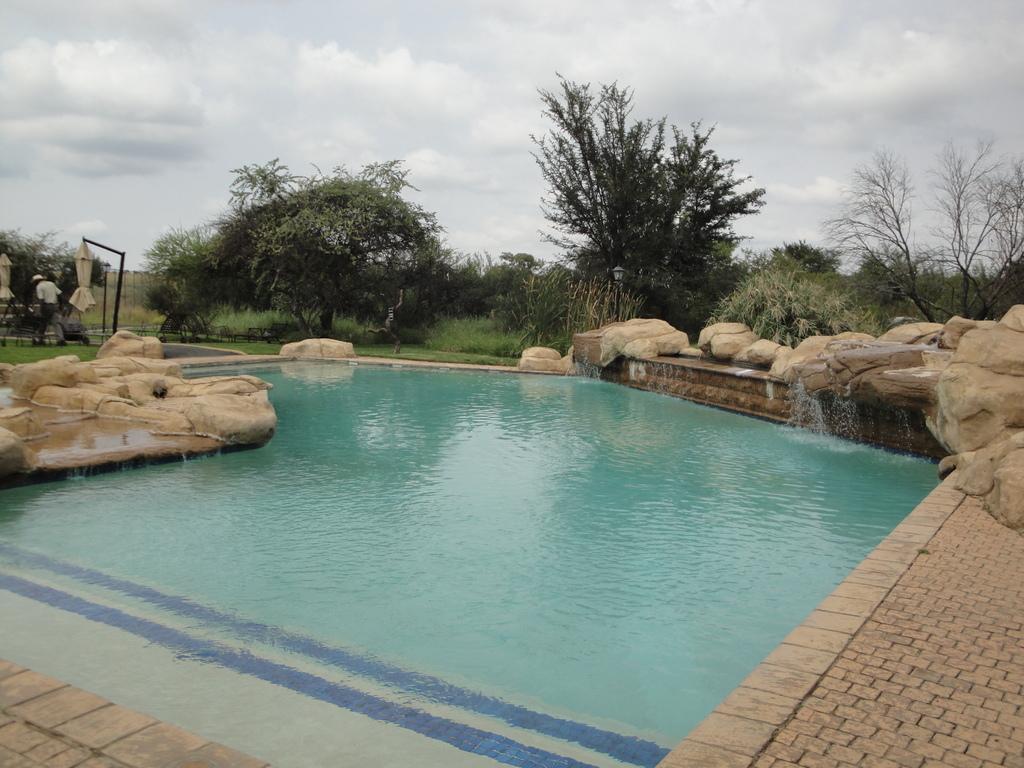In one or two sentences, can you explain what this image depicts? In the foreground of the picture we can see swimming pool and some stone constructions. In the middle of the picture there are trees, pole, grass and a person. At the top it is sky. 